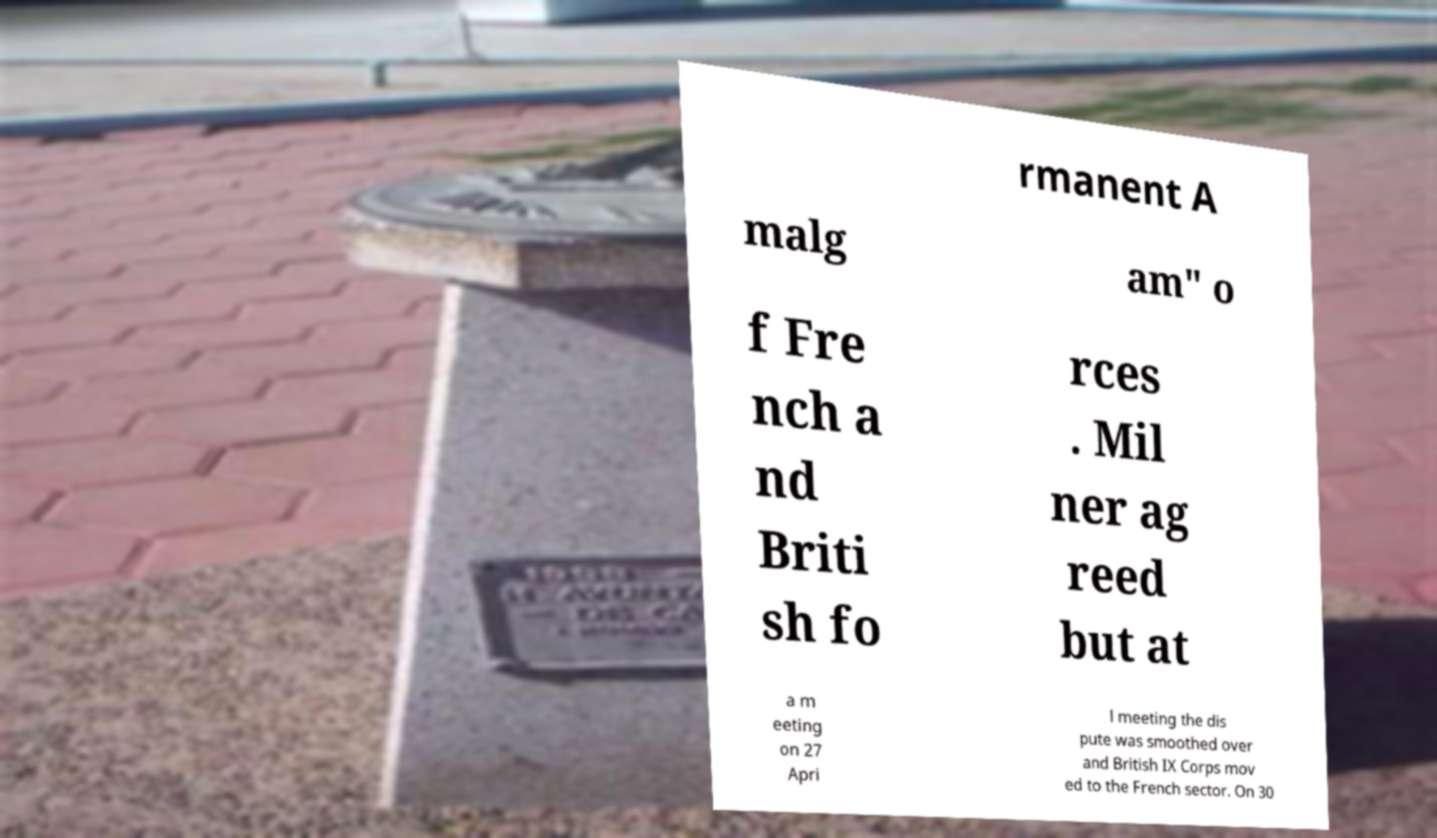Please read and relay the text visible in this image. What does it say? rmanent A malg am" o f Fre nch a nd Briti sh fo rces . Mil ner ag reed but at a m eeting on 27 Apri l meeting the dis pute was smoothed over and British IX Corps mov ed to the French sector. On 30 